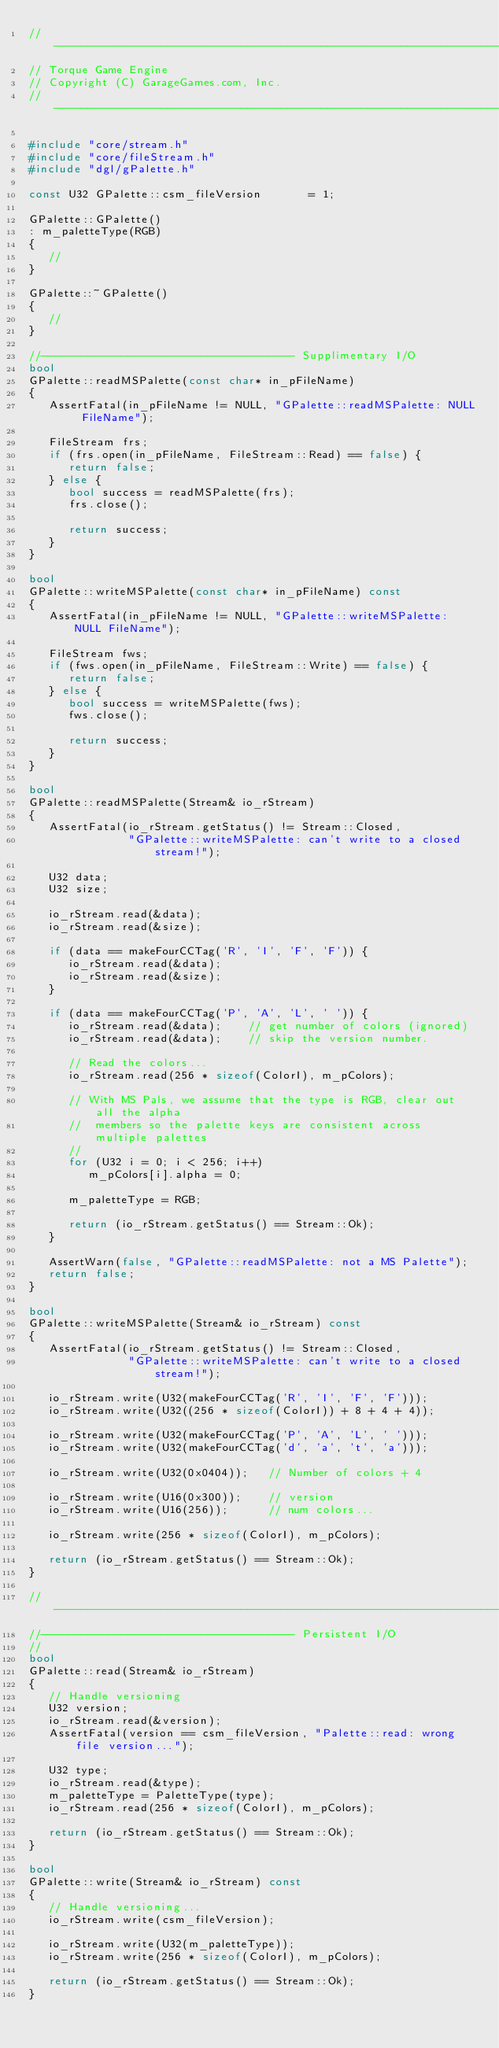<code> <loc_0><loc_0><loc_500><loc_500><_C++_>//-----------------------------------------------------------------------------
// Torque Game Engine
// Copyright (C) GarageGames.com, Inc.
//-----------------------------------------------------------------------------

#include "core/stream.h"
#include "core/fileStream.h"
#include "dgl/gPalette.h"

const U32 GPalette::csm_fileVersion       = 1;

GPalette::GPalette()
: m_paletteType(RGB)
{
   //
}

GPalette::~GPalette()
{
   //
}

//-------------------------------------- Supplimentary I/O
bool
GPalette::readMSPalette(const char* in_pFileName)
{
   AssertFatal(in_pFileName != NULL, "GPalette::readMSPalette: NULL FileName");

   FileStream frs;
   if (frs.open(in_pFileName, FileStream::Read) == false) {
      return false;
   } else {
      bool success = readMSPalette(frs);
      frs.close();

      return success;
   }
}

bool
GPalette::writeMSPalette(const char* in_pFileName) const
{
   AssertFatal(in_pFileName != NULL, "GPalette::writeMSPalette: NULL FileName");

   FileStream fws;
   if (fws.open(in_pFileName, FileStream::Write) == false) {
      return false;
   } else {
      bool success = writeMSPalette(fws);
      fws.close();

      return success;
   }
}

bool
GPalette::readMSPalette(Stream& io_rStream)
{
   AssertFatal(io_rStream.getStatus() != Stream::Closed,
               "GPalette::writeMSPalette: can't write to a closed stream!");

   U32 data;
   U32 size;

   io_rStream.read(&data);
   io_rStream.read(&size);

   if (data == makeFourCCTag('R', 'I', 'F', 'F')) {
      io_rStream.read(&data);
      io_rStream.read(&size);
   }

   if (data == makeFourCCTag('P', 'A', 'L', ' ')) {
      io_rStream.read(&data);    // get number of colors (ignored)
      io_rStream.read(&data);    // skip the version number.

      // Read the colors...
      io_rStream.read(256 * sizeof(ColorI), m_pColors);

      // With MS Pals, we assume that the type is RGB, clear out all the alpha
      //  members so the palette keys are consistent across multiple palettes
      //
      for (U32 i = 0; i < 256; i++)
         m_pColors[i].alpha = 0;

      m_paletteType = RGB;

      return (io_rStream.getStatus() == Stream::Ok);
   }

   AssertWarn(false, "GPalette::readMSPalette: not a MS Palette");
   return false;
}

bool
GPalette::writeMSPalette(Stream& io_rStream) const
{
   AssertFatal(io_rStream.getStatus() != Stream::Closed,
               "GPalette::writeMSPalette: can't write to a closed stream!");

   io_rStream.write(U32(makeFourCCTag('R', 'I', 'F', 'F')));
   io_rStream.write(U32((256 * sizeof(ColorI)) + 8 + 4 + 4));

   io_rStream.write(U32(makeFourCCTag('P', 'A', 'L', ' ')));
   io_rStream.write(U32(makeFourCCTag('d', 'a', 't', 'a')));

   io_rStream.write(U32(0x0404));   // Number of colors + 4

   io_rStream.write(U16(0x300));    // version
   io_rStream.write(U16(256));      // num colors...

   io_rStream.write(256 * sizeof(ColorI), m_pColors);

   return (io_rStream.getStatus() == Stream::Ok);
}

//------------------------------------------------------------------------------
//-------------------------------------- Persistent I/O
//
bool
GPalette::read(Stream& io_rStream)
{
   // Handle versioning
   U32 version;
   io_rStream.read(&version);
   AssertFatal(version == csm_fileVersion, "Palette::read: wrong file version...");

   U32 type;
   io_rStream.read(&type);
   m_paletteType = PaletteType(type);
   io_rStream.read(256 * sizeof(ColorI), m_pColors);

   return (io_rStream.getStatus() == Stream::Ok);
}

bool
GPalette::write(Stream& io_rStream) const
{
   // Handle versioning...
   io_rStream.write(csm_fileVersion);

   io_rStream.write(U32(m_paletteType));
   io_rStream.write(256 * sizeof(ColorI), m_pColors);

   return (io_rStream.getStatus() == Stream::Ok);
}
</code> 